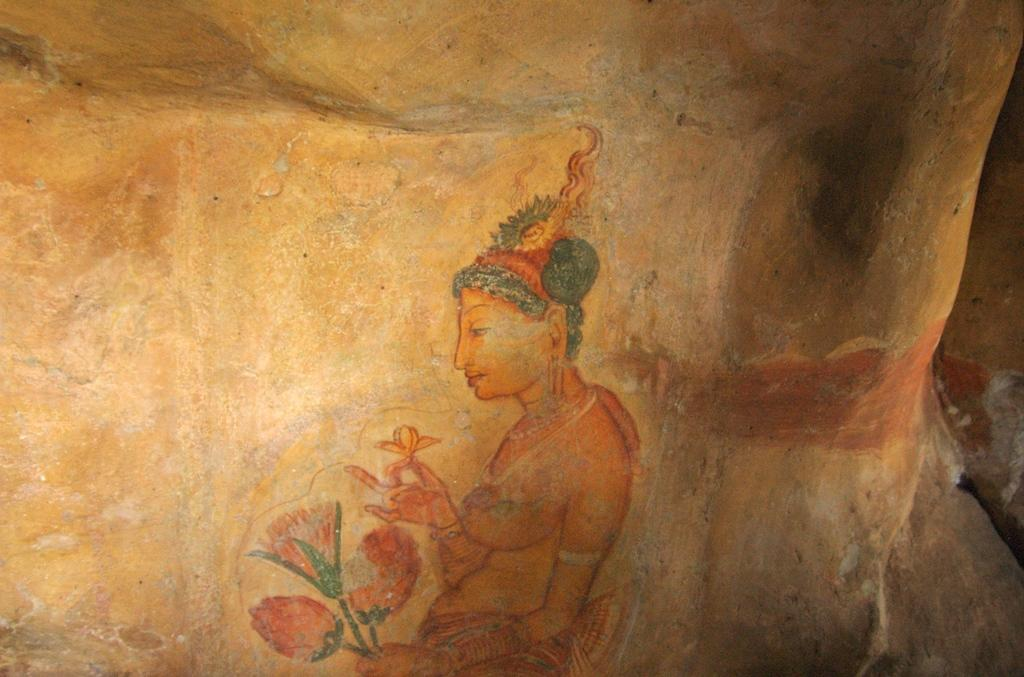What is depicted in the drawing in the image? The image contains a drawing of a woman. What is the woman holding in the drawing? The woman is holding a flower. What is the woman standing on in the drawing? The woman is standing on a stone. How many babies are present in the drawing? There are no babies depicted in the drawing; it features a woman holding a flower and standing on a stone. 